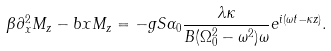Convert formula to latex. <formula><loc_0><loc_0><loc_500><loc_500>\beta \partial _ { x } ^ { 2 } M _ { z } - b x M _ { z } = - g S \alpha _ { 0 } \frac { \lambda \kappa } { B ( \Omega _ { 0 } ^ { 2 } - \omega ^ { 2 } ) \omega } e ^ { i ( \omega t - \kappa z ) } .</formula> 